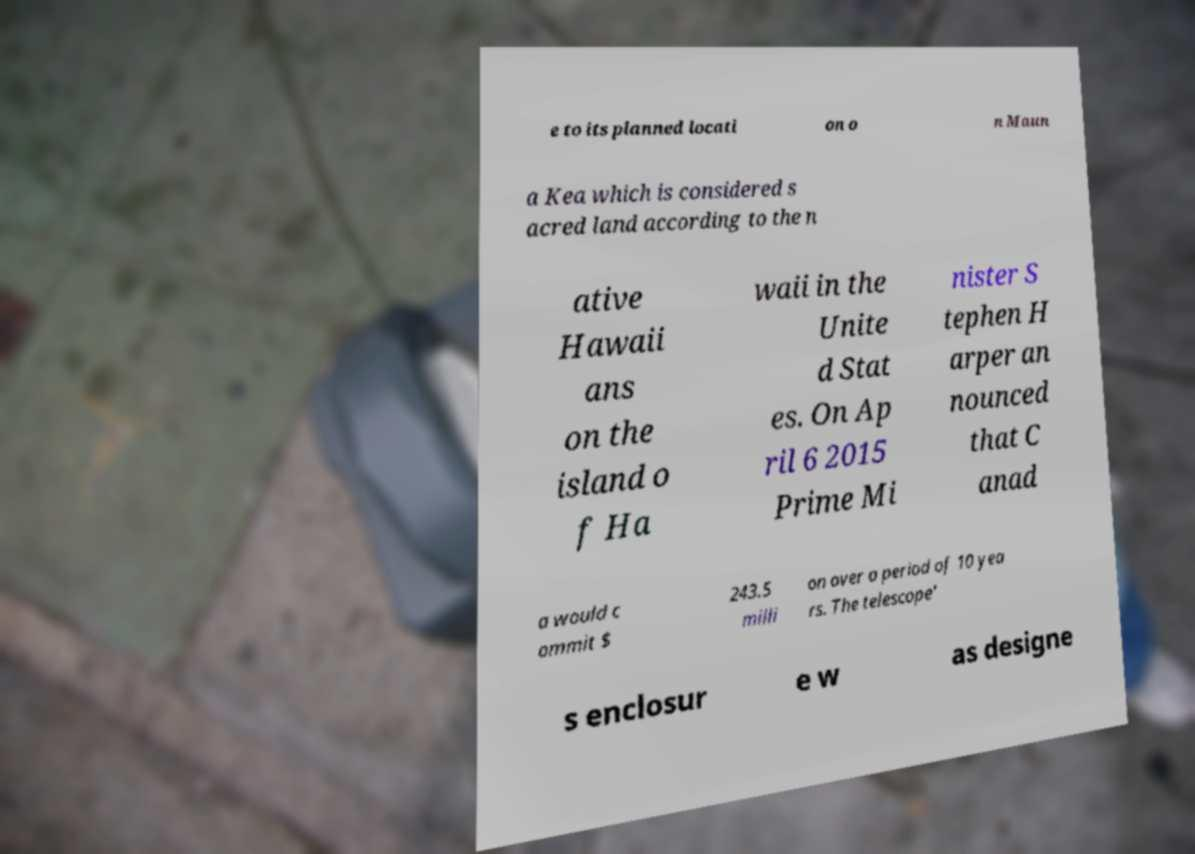Could you extract and type out the text from this image? e to its planned locati on o n Maun a Kea which is considered s acred land according to the n ative Hawaii ans on the island o f Ha waii in the Unite d Stat es. On Ap ril 6 2015 Prime Mi nister S tephen H arper an nounced that C anad a would c ommit $ 243.5 milli on over a period of 10 yea rs. The telescope' s enclosur e w as designe 